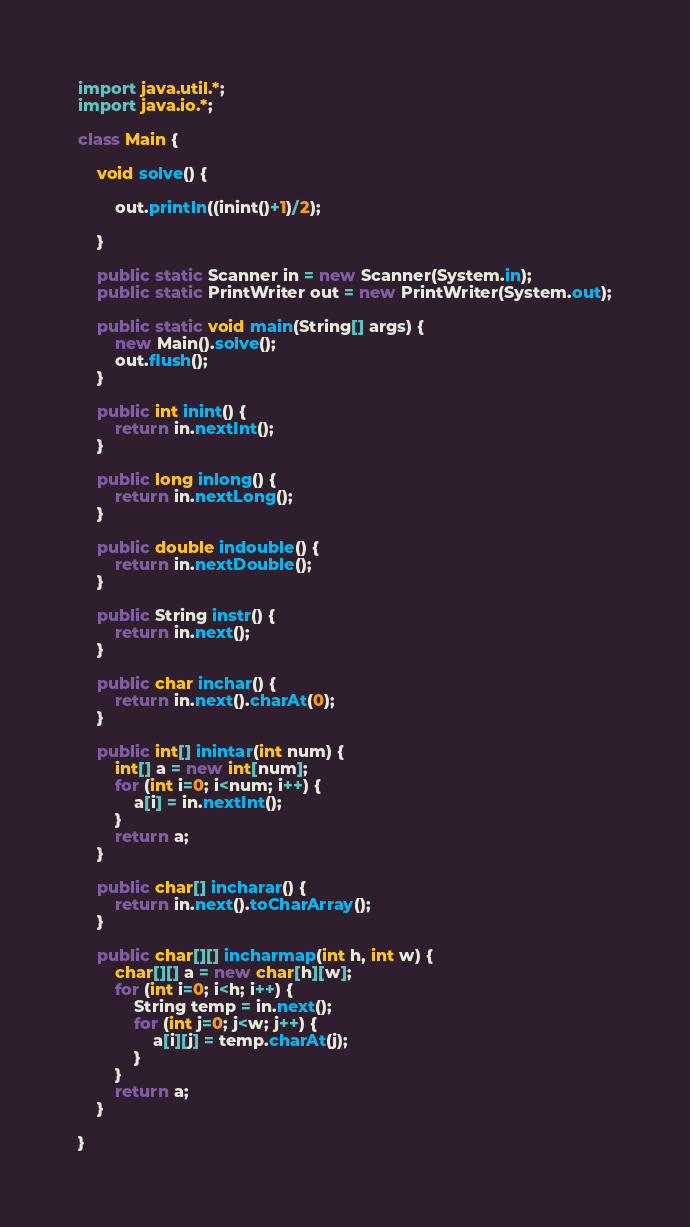<code> <loc_0><loc_0><loc_500><loc_500><_Java_>import java.util.*;
import java.io.*;

class Main {

	void solve() {
		
		out.println((inint()+1)/2);
		
	}

	public static Scanner in = new Scanner(System.in);
	public static PrintWriter out = new PrintWriter(System.out);

	public static void main(String[] args) {
		new Main().solve();
		out.flush();
	}

	public int inint() {
		return in.nextInt();
	}

	public long inlong() {
		return in.nextLong();
	}

	public double indouble() {
		return in.nextDouble();
	}

	public String instr() {
		return in.next();
	}

	public char inchar() {
		return in.next().charAt(0);
	}

	public int[] inintar(int num) {
		int[] a = new int[num];
		for (int i=0; i<num; i++) {
			a[i] = in.nextInt();
		}
		return a;
	}

	public char[] incharar() {
		return in.next().toCharArray();
	}

	public char[][] incharmap(int h, int w) {
		char[][] a = new char[h][w];
		for (int i=0; i<h; i++) {
			String temp = in.next();
			for (int j=0; j<w; j++) {
				a[i][j] = temp.charAt(j);
			}
		}
		return a;
	}

}</code> 